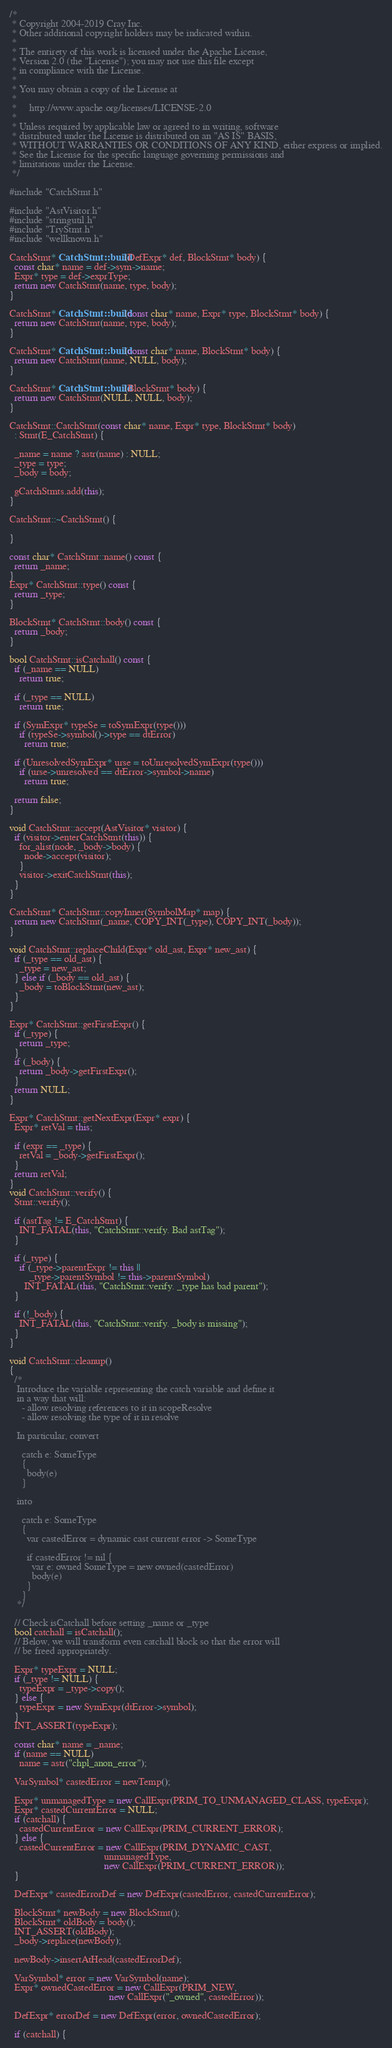Convert code to text. <code><loc_0><loc_0><loc_500><loc_500><_C++_>/*
 * Copyright 2004-2019 Cray Inc.
 * Other additional copyright holders may be indicated within.
 *
 * The entirety of this work is licensed under the Apache License,
 * Version 2.0 (the "License"); you may not use this file except
 * in compliance with the License.
 *
 * You may obtain a copy of the License at
 *
 *     http://www.apache.org/licenses/LICENSE-2.0
 *
 * Unless required by applicable law or agreed to in writing, software
 * distributed under the License is distributed on an "AS IS" BASIS,
 * WITHOUT WARRANTIES OR CONDITIONS OF ANY KIND, either express or implied.
 * See the License for the specific language governing permissions and
 * limitations under the License.
 */

#include "CatchStmt.h"

#include "AstVisitor.h"
#include "stringutil.h"
#include "TryStmt.h"
#include "wellknown.h"

CatchStmt* CatchStmt::build(DefExpr* def, BlockStmt* body) {
  const char* name = def->sym->name;
  Expr* type = def->exprType;
  return new CatchStmt(name, type, body);
}

CatchStmt* CatchStmt::build(const char* name, Expr* type, BlockStmt* body) {
  return new CatchStmt(name, type, body);
}

CatchStmt* CatchStmt::build(const char* name, BlockStmt* body) {
  return new CatchStmt(name, NULL, body);
}

CatchStmt* CatchStmt::build(BlockStmt* body) {
  return new CatchStmt(NULL, NULL, body);
}

CatchStmt::CatchStmt(const char* name, Expr* type, BlockStmt* body)
  : Stmt(E_CatchStmt) {

  _name = name ? astr(name) : NULL;
  _type = type;
  _body = body;

  gCatchStmts.add(this);
}

CatchStmt::~CatchStmt() {

}

const char* CatchStmt::name() const {
  return _name;
}
Expr* CatchStmt::type() const {
  return _type;
}

BlockStmt* CatchStmt::body() const {
  return _body;
}

bool CatchStmt::isCatchall() const {
  if (_name == NULL)
    return true;

  if (_type == NULL)
    return true;

  if (SymExpr* typeSe = toSymExpr(type()))
    if (typeSe->symbol()->type == dtError)
      return true;

  if (UnresolvedSymExpr* urse = toUnresolvedSymExpr(type()))
    if (urse->unresolved == dtError->symbol->name)
      return true;

  return false;
}

void CatchStmt::accept(AstVisitor* visitor) {
  if (visitor->enterCatchStmt(this)) {
    for_alist(node, _body->body) {
      node->accept(visitor);
    }
    visitor->exitCatchStmt(this);
  }
}

CatchStmt* CatchStmt::copyInner(SymbolMap* map) {
  return new CatchStmt(_name, COPY_INT(_type), COPY_INT(_body));
}

void CatchStmt::replaceChild(Expr* old_ast, Expr* new_ast) {
  if (_type == old_ast) {
    _type = new_ast;
  } else if (_body == old_ast) {
    _body = toBlockStmt(new_ast);
  }
}

Expr* CatchStmt::getFirstExpr() {
  if (_type) {
    return _type;
  }
  if (_body) {
    return _body->getFirstExpr();
  }
  return NULL;
}

Expr* CatchStmt::getNextExpr(Expr* expr) {
  Expr* retVal = this;

  if (expr == _type) {
    retVal = _body->getFirstExpr();
  }
  return retVal;
}
void CatchStmt::verify() {
  Stmt::verify();

  if (astTag != E_CatchStmt) {
    INT_FATAL(this, "CatchStmt::verify. Bad astTag");
  }

  if (_type) {
    if (_type->parentExpr != this ||
        _type->parentSymbol != this->parentSymbol)
      INT_FATAL(this, "CatchStmt::verify. _type has bad parent");
  }

  if (!_body) {
    INT_FATAL(this, "CatchStmt::verify. _body is missing");
  }
}

void CatchStmt::cleanup()
{
  /*
   Introduce the variable representing the catch variable and define it
   in a way that will:
     - allow resolving references to it in scopeResolve
     - allow resolving the type of it in resolve

   In particular, convert

     catch e: SomeType
     {
       body(e)
     }

   into

     catch e: SomeType
     {
       var castedError = dynamic cast current error -> SomeType

       if castedError != nil {
         var e: owned SomeType = new owned(castedError)
         body(e)
       }
     }
   */

  // Check isCatchall before setting _name or _type
  bool catchall = isCatchall();
  // Below, we will transform even catchall block so that the error will
  // be freed appropriately.

  Expr* typeExpr = NULL;
  if (_type != NULL) {
    typeExpr = _type->copy();
  } else {
    typeExpr = new SymExpr(dtError->symbol);
  }
  INT_ASSERT(typeExpr);

  const char* name = _name;
  if (name == NULL)
    name = astr("chpl_anon_error");

  VarSymbol* castedError = newTemp();

  Expr* unmanagedType = new CallExpr(PRIM_TO_UNMANAGED_CLASS, typeExpr);
  Expr* castedCurrentError = NULL;
  if (catchall) {
    castedCurrentError = new CallExpr(PRIM_CURRENT_ERROR);
  } else {
    castedCurrentError = new CallExpr(PRIM_DYNAMIC_CAST,
                                      unmanagedType,
                                      new CallExpr(PRIM_CURRENT_ERROR));
  }

  DefExpr* castedErrorDef = new DefExpr(castedError, castedCurrentError);

  BlockStmt* newBody = new BlockStmt();
  BlockStmt* oldBody = body();
  INT_ASSERT(oldBody);
  _body->replace(newBody);

  newBody->insertAtHead(castedErrorDef);

  VarSymbol* error = new VarSymbol(name);
  Expr* ownedCastedError = new CallExpr(PRIM_NEW,
                                        new CallExpr("_owned", castedError));

  DefExpr* errorDef = new DefExpr(error, ownedCastedError);

  if (catchall) {</code> 